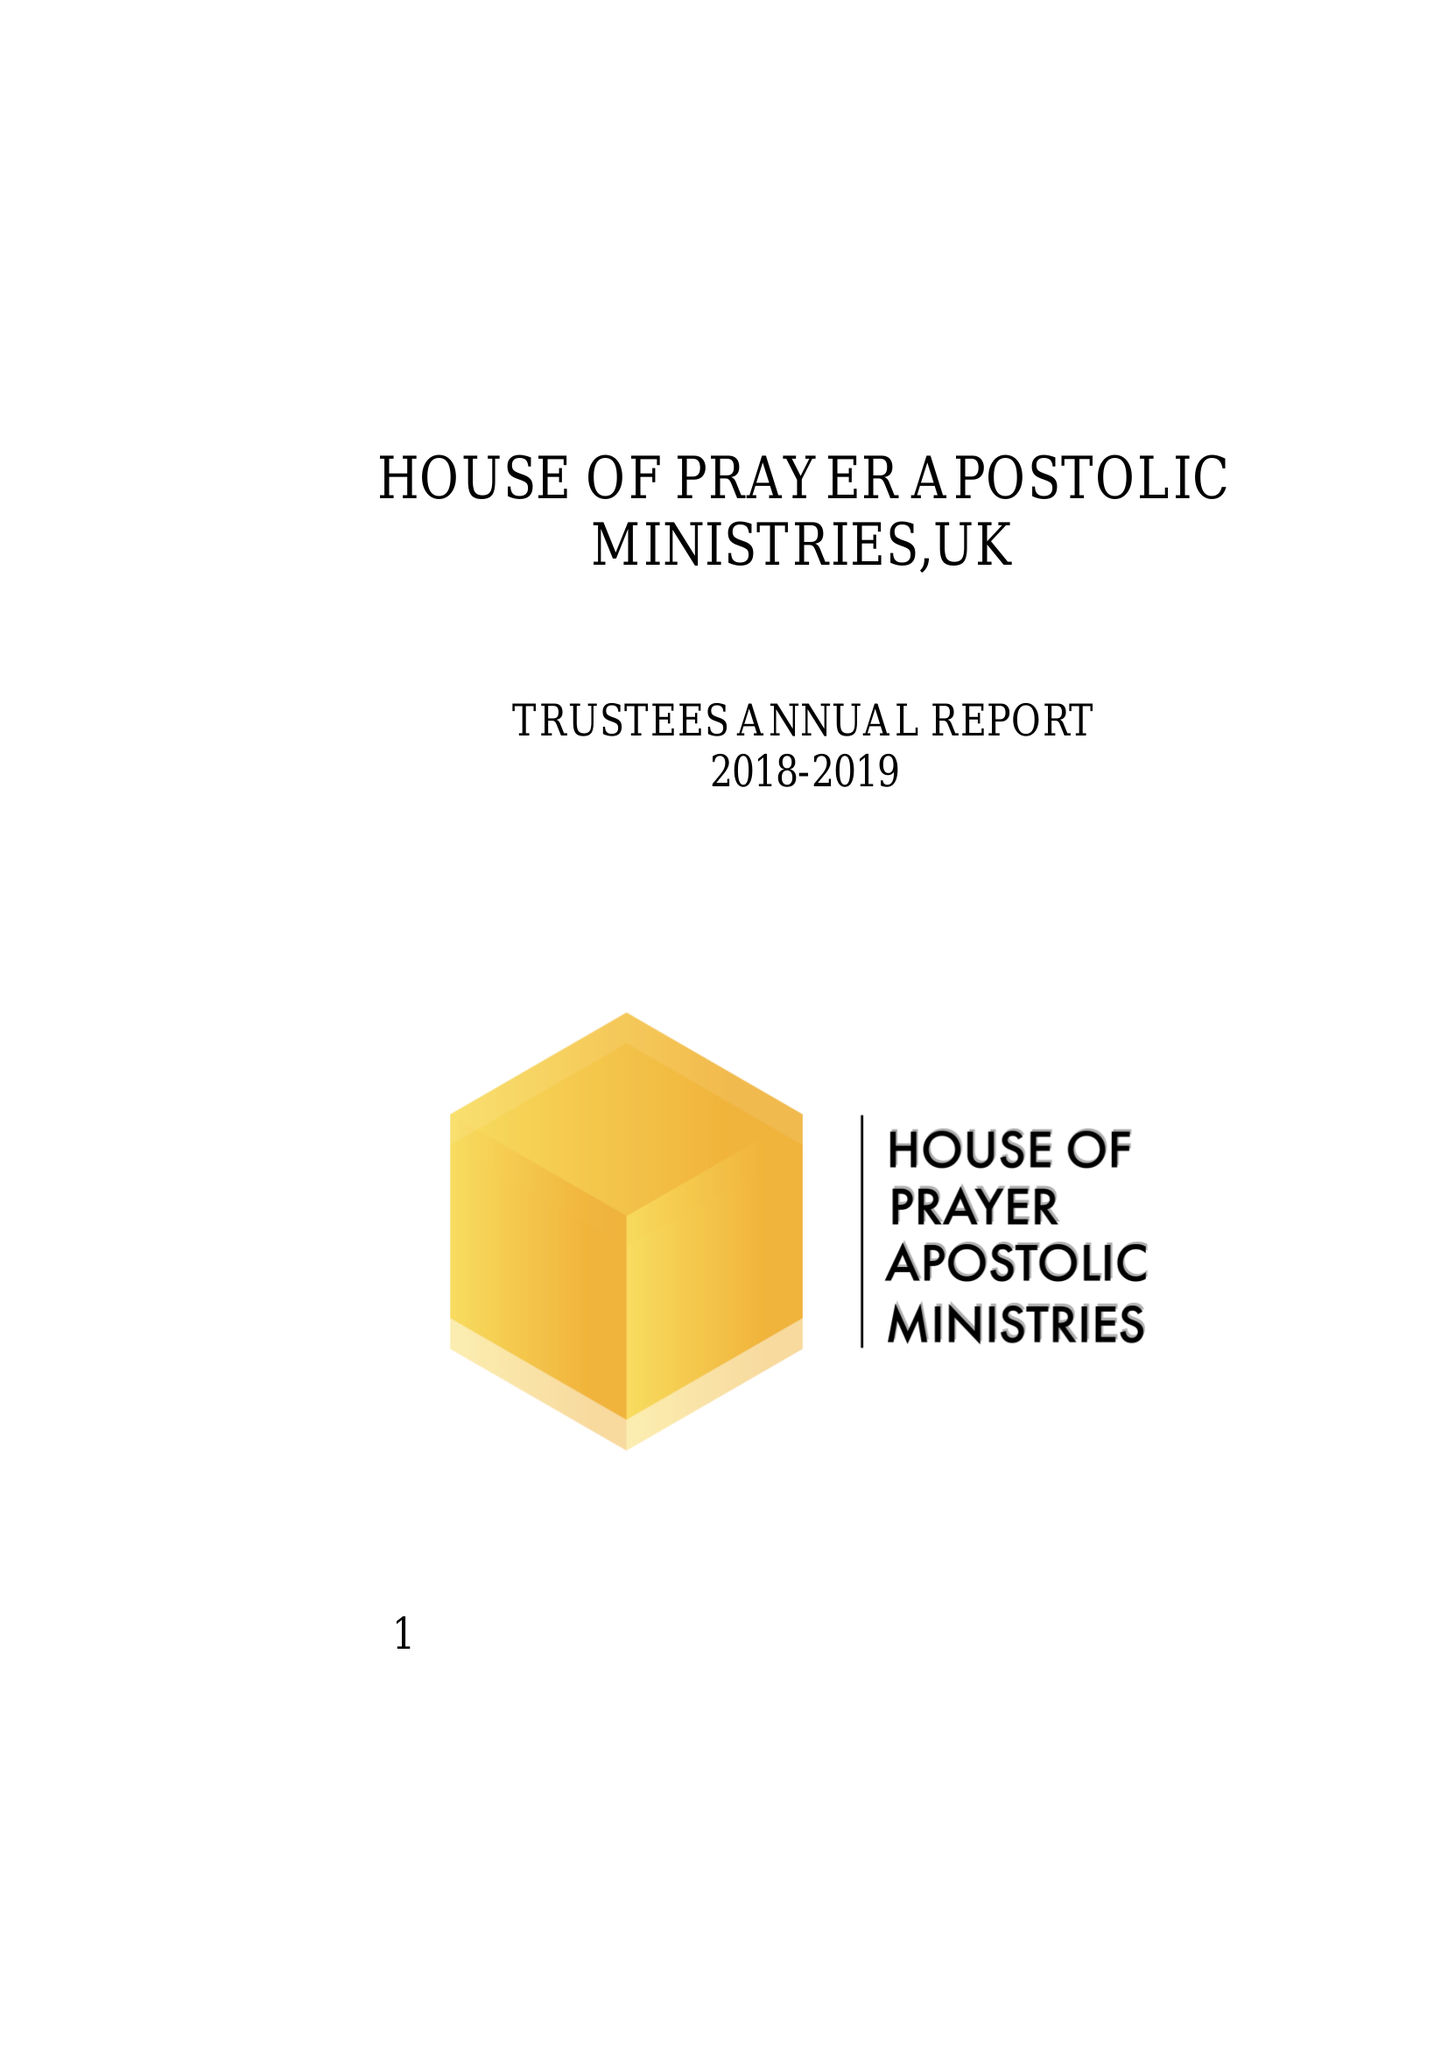What is the value for the address__street_line?
Answer the question using a single word or phrase. YARM ROAD 